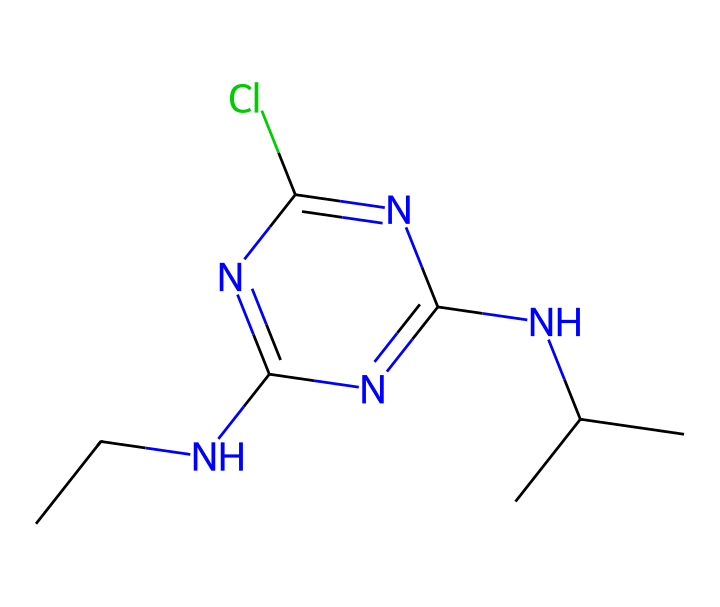What is the molecular formula of atrazine? To derive the molecular formula, we count the number of each type of atom represented in the SMILES: there are 10 Carbon (C), 14 Hydrogen (H), 3 Nitrogen (N), and 1 Chlorine (Cl) atom. So, we combine these counts into the formula: C10H14ClN5.
Answer: C10H14ClN5 How many rings are present in the atrazine structure? Looking closely at the structure indicated by the SMILES, we can see there are no separate cycles or closed loops. The structure primarily consists of a linear arrangement of atoms and a nitrogen-containing aromatic ring. Thus, the count of rings is zero.
Answer: 0 What types of functional groups are present in atrazine? Analyzing the SMILES structure, we can identify amino groups (-NH2), which are common in herbicides. The presence of the chlorine atom also indicates it belongs to the category of chlorinated compounds. Thus, the functional group can be identified as amine and chlorinated.
Answer: amine and chlorinated What is the role of the chlorine atom in atrazine's effectiveness as a herbicide? The chlorine atom in atrazine plays a crucial role in its herbicidal properties. It is known to enhance the lipophilicity of the compound, allowing it to penetrate plant tissues more effectively. Additionally, chlorinated compounds often interact strongly with biological targets, enhancing their activity.
Answer: enhance lipophilicity Which element in atrazine contributes to its basic properties? The nitrogen atoms in the SMILES structure are primarily responsible for the basic properties of atrazine. Nitrogen typically has a lone pair, allowing it to act as a proton acceptor, hence contributing to basicity.
Answer: nitrogen How does the presence of the tert-butyl group influence atrazine's function? The tert-butyl group in atrazine provides steric bulk that can improve the herbicide's selectivity, helping it to inhibit specific enzyme activity in target weeds while reducing potential harm to non-target species. This structural feature allows for better binding to biological targets often associated with herbicidal action.
Answer: improves selectivity 